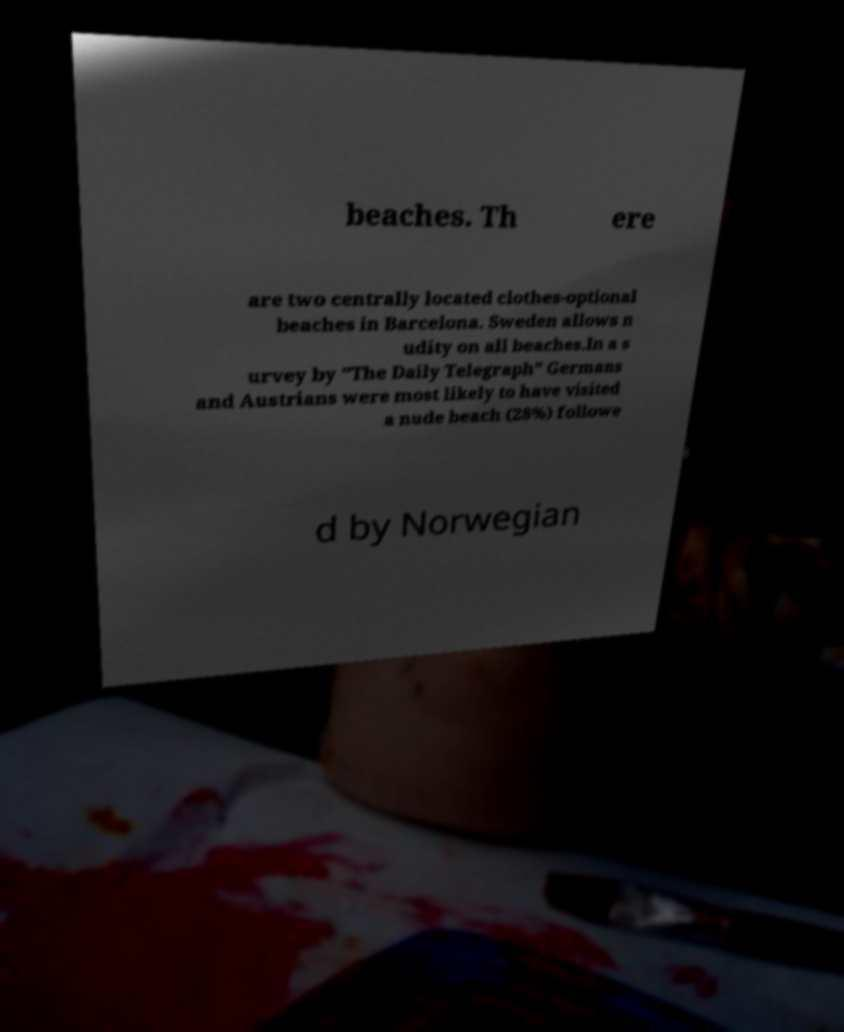Please identify and transcribe the text found in this image. beaches. Th ere are two centrally located clothes-optional beaches in Barcelona. Sweden allows n udity on all beaches.In a s urvey by "The Daily Telegraph" Germans and Austrians were most likely to have visited a nude beach (28%) followe d by Norwegian 